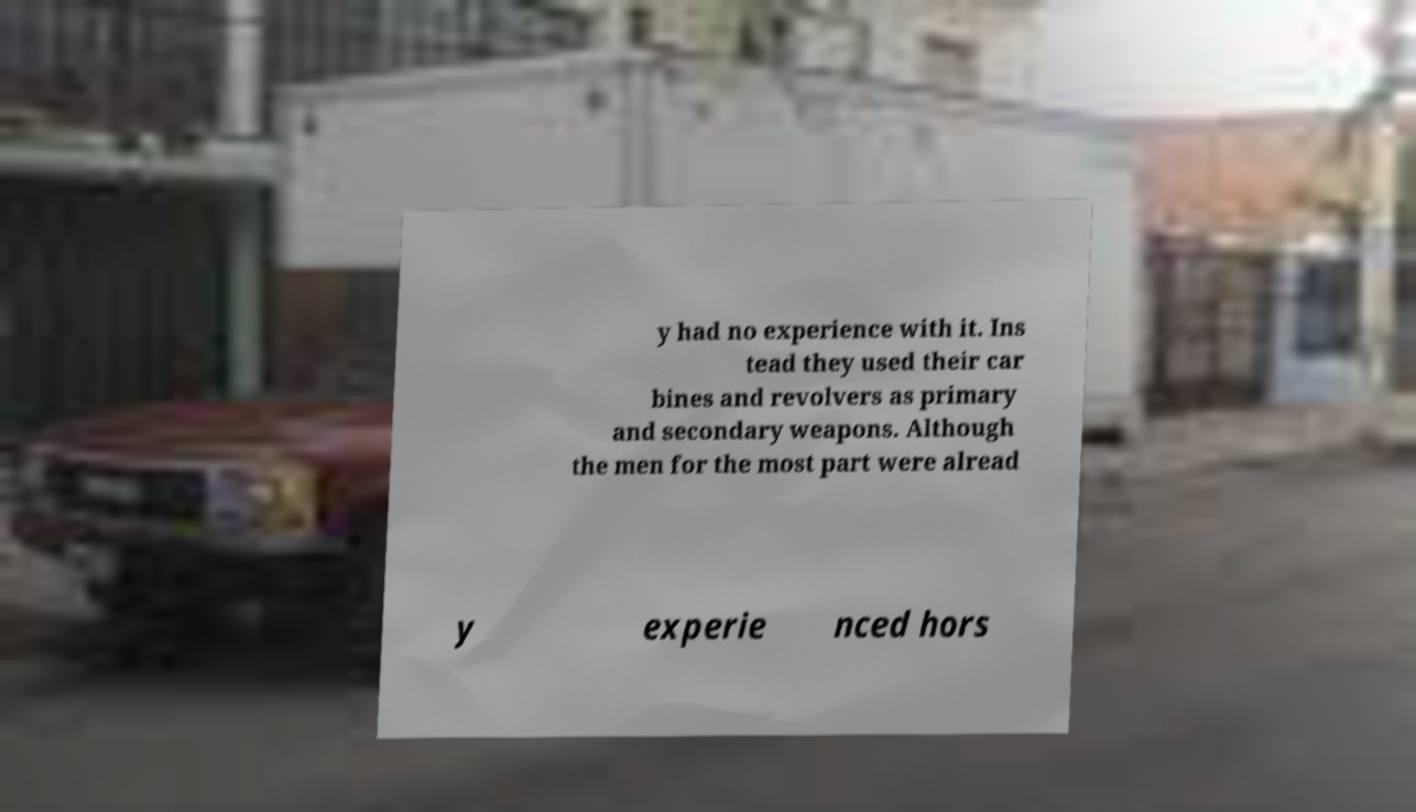I need the written content from this picture converted into text. Can you do that? y had no experience with it. Ins tead they used their car bines and revolvers as primary and secondary weapons. Although the men for the most part were alread y experie nced hors 